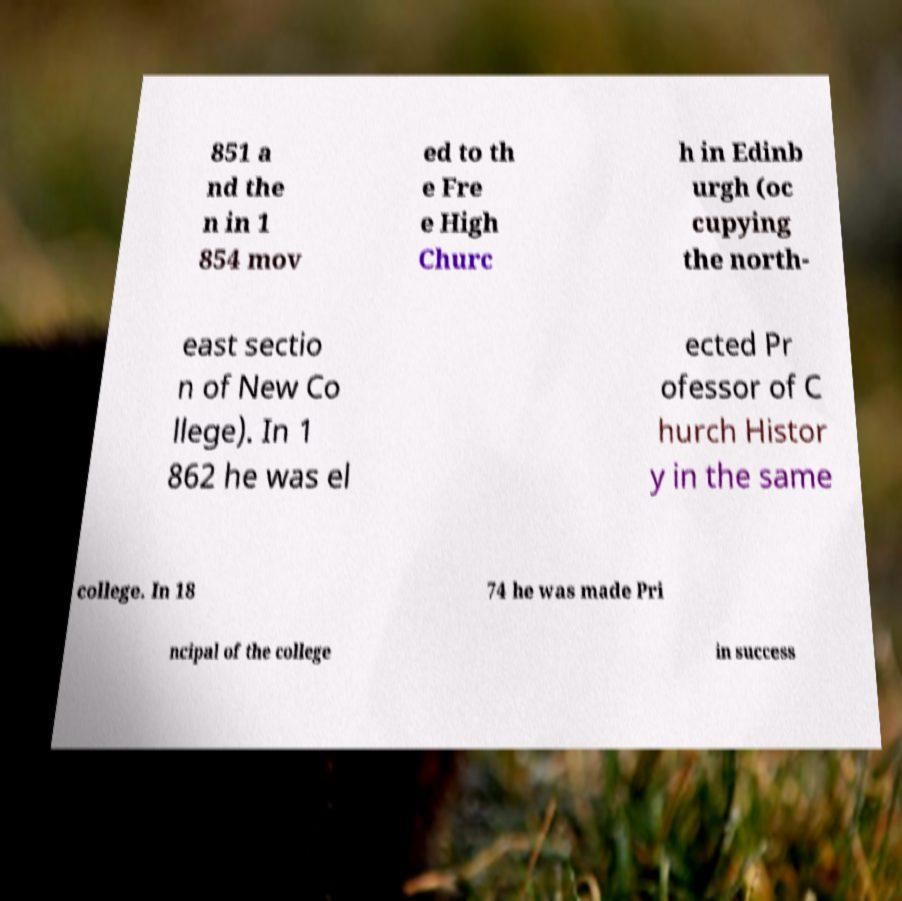Could you assist in decoding the text presented in this image and type it out clearly? 851 a nd the n in 1 854 mov ed to th e Fre e High Churc h in Edinb urgh (oc cupying the north- east sectio n of New Co llege). In 1 862 he was el ected Pr ofessor of C hurch Histor y in the same college. In 18 74 he was made Pri ncipal of the college in success 